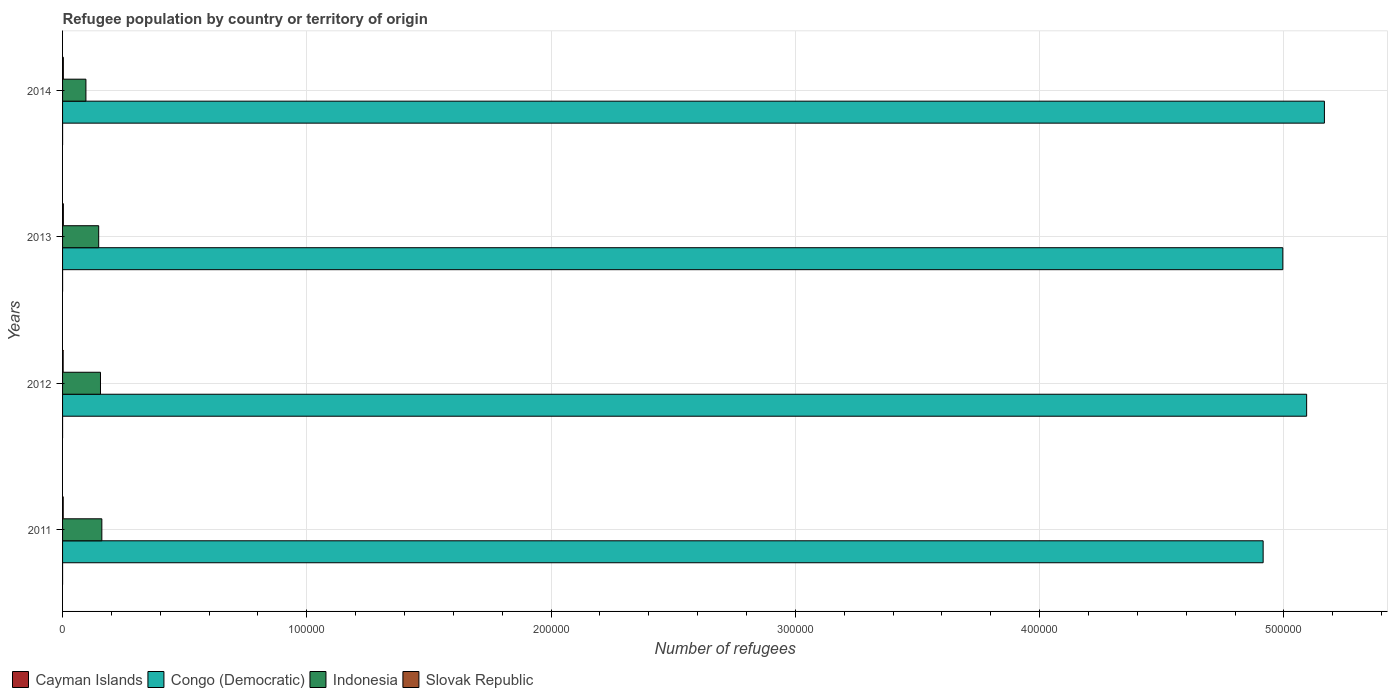How many groups of bars are there?
Keep it short and to the point. 4. Are the number of bars per tick equal to the number of legend labels?
Ensure brevity in your answer.  Yes. Are the number of bars on each tick of the Y-axis equal?
Offer a terse response. Yes. How many bars are there on the 3rd tick from the top?
Provide a short and direct response. 4. What is the number of refugees in Slovak Republic in 2014?
Offer a terse response. 319. Across all years, what is the maximum number of refugees in Congo (Democratic)?
Ensure brevity in your answer.  5.17e+05. Across all years, what is the minimum number of refugees in Indonesia?
Provide a short and direct response. 9562. What is the total number of refugees in Congo (Democratic) in the graph?
Your response must be concise. 2.02e+06. What is the difference between the number of refugees in Slovak Republic in 2011 and that in 2012?
Offer a terse response. 30. What is the difference between the number of refugees in Indonesia in 2011 and the number of refugees in Congo (Democratic) in 2013?
Provide a short and direct response. -4.83e+05. What is the average number of refugees in Slovak Republic per year?
Your answer should be compact. 287.5. In the year 2013, what is the difference between the number of refugees in Slovak Republic and number of refugees in Indonesia?
Offer a very short reply. -1.45e+04. What is the ratio of the number of refugees in Slovak Republic in 2011 to that in 2014?
Ensure brevity in your answer.  0.84. What is the difference between the highest and the second highest number of refugees in Cayman Islands?
Your answer should be compact. 0. What is the difference between the highest and the lowest number of refugees in Indonesia?
Offer a terse response. 6517. In how many years, is the number of refugees in Indonesia greater than the average number of refugees in Indonesia taken over all years?
Provide a short and direct response. 3. Is the sum of the number of refugees in Congo (Democratic) in 2011 and 2014 greater than the maximum number of refugees in Cayman Islands across all years?
Your response must be concise. Yes. What does the 2nd bar from the top in 2012 represents?
Give a very brief answer. Indonesia. How many years are there in the graph?
Your answer should be very brief. 4. Are the values on the major ticks of X-axis written in scientific E-notation?
Your answer should be very brief. No. What is the title of the graph?
Your response must be concise. Refugee population by country or territory of origin. What is the label or title of the X-axis?
Your answer should be very brief. Number of refugees. What is the Number of refugees of Cayman Islands in 2011?
Make the answer very short. 1. What is the Number of refugees of Congo (Democratic) in 2011?
Your answer should be very brief. 4.91e+05. What is the Number of refugees of Indonesia in 2011?
Your response must be concise. 1.61e+04. What is the Number of refugees of Slovak Republic in 2011?
Your answer should be very brief. 269. What is the Number of refugees in Congo (Democratic) in 2012?
Your response must be concise. 5.09e+05. What is the Number of refugees in Indonesia in 2012?
Keep it short and to the point. 1.55e+04. What is the Number of refugees of Slovak Republic in 2012?
Your answer should be very brief. 239. What is the Number of refugees in Congo (Democratic) in 2013?
Ensure brevity in your answer.  5.00e+05. What is the Number of refugees of Indonesia in 2013?
Give a very brief answer. 1.48e+04. What is the Number of refugees of Slovak Republic in 2013?
Provide a succinct answer. 323. What is the Number of refugees in Congo (Democratic) in 2014?
Offer a terse response. 5.17e+05. What is the Number of refugees in Indonesia in 2014?
Keep it short and to the point. 9562. What is the Number of refugees in Slovak Republic in 2014?
Provide a succinct answer. 319. Across all years, what is the maximum Number of refugees in Cayman Islands?
Your response must be concise. 6. Across all years, what is the maximum Number of refugees of Congo (Democratic)?
Make the answer very short. 5.17e+05. Across all years, what is the maximum Number of refugees of Indonesia?
Provide a succinct answer. 1.61e+04. Across all years, what is the maximum Number of refugees of Slovak Republic?
Your answer should be very brief. 323. Across all years, what is the minimum Number of refugees of Congo (Democratic)?
Your response must be concise. 4.91e+05. Across all years, what is the minimum Number of refugees of Indonesia?
Provide a short and direct response. 9562. Across all years, what is the minimum Number of refugees of Slovak Republic?
Make the answer very short. 239. What is the total Number of refugees in Congo (Democratic) in the graph?
Provide a short and direct response. 2.02e+06. What is the total Number of refugees in Indonesia in the graph?
Offer a terse response. 5.60e+04. What is the total Number of refugees in Slovak Republic in the graph?
Your response must be concise. 1150. What is the difference between the Number of refugees of Congo (Democratic) in 2011 and that in 2012?
Give a very brief answer. -1.78e+04. What is the difference between the Number of refugees in Indonesia in 2011 and that in 2012?
Offer a very short reply. 556. What is the difference between the Number of refugees of Slovak Republic in 2011 and that in 2012?
Keep it short and to the point. 30. What is the difference between the Number of refugees in Congo (Democratic) in 2011 and that in 2013?
Offer a terse response. -8060. What is the difference between the Number of refugees of Indonesia in 2011 and that in 2013?
Provide a short and direct response. 1293. What is the difference between the Number of refugees of Slovak Republic in 2011 and that in 2013?
Give a very brief answer. -54. What is the difference between the Number of refugees in Cayman Islands in 2011 and that in 2014?
Your answer should be very brief. -5. What is the difference between the Number of refugees in Congo (Democratic) in 2011 and that in 2014?
Your answer should be very brief. -2.51e+04. What is the difference between the Number of refugees of Indonesia in 2011 and that in 2014?
Provide a short and direct response. 6517. What is the difference between the Number of refugees of Slovak Republic in 2011 and that in 2014?
Provide a short and direct response. -50. What is the difference between the Number of refugees of Congo (Democratic) in 2012 and that in 2013?
Make the answer very short. 9749. What is the difference between the Number of refugees of Indonesia in 2012 and that in 2013?
Ensure brevity in your answer.  737. What is the difference between the Number of refugees of Slovak Republic in 2012 and that in 2013?
Your answer should be compact. -84. What is the difference between the Number of refugees in Cayman Islands in 2012 and that in 2014?
Provide a succinct answer. -5. What is the difference between the Number of refugees of Congo (Democratic) in 2012 and that in 2014?
Your answer should be very brief. -7272. What is the difference between the Number of refugees in Indonesia in 2012 and that in 2014?
Keep it short and to the point. 5961. What is the difference between the Number of refugees of Slovak Republic in 2012 and that in 2014?
Provide a short and direct response. -80. What is the difference between the Number of refugees in Congo (Democratic) in 2013 and that in 2014?
Give a very brief answer. -1.70e+04. What is the difference between the Number of refugees of Indonesia in 2013 and that in 2014?
Give a very brief answer. 5224. What is the difference between the Number of refugees of Cayman Islands in 2011 and the Number of refugees of Congo (Democratic) in 2012?
Your response must be concise. -5.09e+05. What is the difference between the Number of refugees in Cayman Islands in 2011 and the Number of refugees in Indonesia in 2012?
Provide a short and direct response. -1.55e+04. What is the difference between the Number of refugees in Cayman Islands in 2011 and the Number of refugees in Slovak Republic in 2012?
Offer a terse response. -238. What is the difference between the Number of refugees of Congo (Democratic) in 2011 and the Number of refugees of Indonesia in 2012?
Offer a very short reply. 4.76e+05. What is the difference between the Number of refugees of Congo (Democratic) in 2011 and the Number of refugees of Slovak Republic in 2012?
Your answer should be compact. 4.91e+05. What is the difference between the Number of refugees of Indonesia in 2011 and the Number of refugees of Slovak Republic in 2012?
Keep it short and to the point. 1.58e+04. What is the difference between the Number of refugees of Cayman Islands in 2011 and the Number of refugees of Congo (Democratic) in 2013?
Keep it short and to the point. -5.00e+05. What is the difference between the Number of refugees of Cayman Islands in 2011 and the Number of refugees of Indonesia in 2013?
Ensure brevity in your answer.  -1.48e+04. What is the difference between the Number of refugees of Cayman Islands in 2011 and the Number of refugees of Slovak Republic in 2013?
Offer a terse response. -322. What is the difference between the Number of refugees in Congo (Democratic) in 2011 and the Number of refugees in Indonesia in 2013?
Provide a succinct answer. 4.77e+05. What is the difference between the Number of refugees of Congo (Democratic) in 2011 and the Number of refugees of Slovak Republic in 2013?
Give a very brief answer. 4.91e+05. What is the difference between the Number of refugees of Indonesia in 2011 and the Number of refugees of Slovak Republic in 2013?
Provide a short and direct response. 1.58e+04. What is the difference between the Number of refugees of Cayman Islands in 2011 and the Number of refugees of Congo (Democratic) in 2014?
Your response must be concise. -5.17e+05. What is the difference between the Number of refugees in Cayman Islands in 2011 and the Number of refugees in Indonesia in 2014?
Offer a terse response. -9561. What is the difference between the Number of refugees of Cayman Islands in 2011 and the Number of refugees of Slovak Republic in 2014?
Your response must be concise. -318. What is the difference between the Number of refugees of Congo (Democratic) in 2011 and the Number of refugees of Indonesia in 2014?
Make the answer very short. 4.82e+05. What is the difference between the Number of refugees of Congo (Democratic) in 2011 and the Number of refugees of Slovak Republic in 2014?
Your response must be concise. 4.91e+05. What is the difference between the Number of refugees of Indonesia in 2011 and the Number of refugees of Slovak Republic in 2014?
Your response must be concise. 1.58e+04. What is the difference between the Number of refugees of Cayman Islands in 2012 and the Number of refugees of Congo (Democratic) in 2013?
Provide a succinct answer. -5.00e+05. What is the difference between the Number of refugees in Cayman Islands in 2012 and the Number of refugees in Indonesia in 2013?
Ensure brevity in your answer.  -1.48e+04. What is the difference between the Number of refugees of Cayman Islands in 2012 and the Number of refugees of Slovak Republic in 2013?
Make the answer very short. -322. What is the difference between the Number of refugees in Congo (Democratic) in 2012 and the Number of refugees in Indonesia in 2013?
Give a very brief answer. 4.95e+05. What is the difference between the Number of refugees of Congo (Democratic) in 2012 and the Number of refugees of Slovak Republic in 2013?
Offer a terse response. 5.09e+05. What is the difference between the Number of refugees of Indonesia in 2012 and the Number of refugees of Slovak Republic in 2013?
Ensure brevity in your answer.  1.52e+04. What is the difference between the Number of refugees of Cayman Islands in 2012 and the Number of refugees of Congo (Democratic) in 2014?
Your response must be concise. -5.17e+05. What is the difference between the Number of refugees in Cayman Islands in 2012 and the Number of refugees in Indonesia in 2014?
Offer a very short reply. -9561. What is the difference between the Number of refugees of Cayman Islands in 2012 and the Number of refugees of Slovak Republic in 2014?
Provide a short and direct response. -318. What is the difference between the Number of refugees in Congo (Democratic) in 2012 and the Number of refugees in Indonesia in 2014?
Your answer should be compact. 5.00e+05. What is the difference between the Number of refugees of Congo (Democratic) in 2012 and the Number of refugees of Slovak Republic in 2014?
Your answer should be compact. 5.09e+05. What is the difference between the Number of refugees in Indonesia in 2012 and the Number of refugees in Slovak Republic in 2014?
Keep it short and to the point. 1.52e+04. What is the difference between the Number of refugees in Cayman Islands in 2013 and the Number of refugees in Congo (Democratic) in 2014?
Make the answer very short. -5.17e+05. What is the difference between the Number of refugees in Cayman Islands in 2013 and the Number of refugees in Indonesia in 2014?
Keep it short and to the point. -9556. What is the difference between the Number of refugees in Cayman Islands in 2013 and the Number of refugees in Slovak Republic in 2014?
Provide a succinct answer. -313. What is the difference between the Number of refugees in Congo (Democratic) in 2013 and the Number of refugees in Indonesia in 2014?
Your response must be concise. 4.90e+05. What is the difference between the Number of refugees in Congo (Democratic) in 2013 and the Number of refugees in Slovak Republic in 2014?
Provide a succinct answer. 4.99e+05. What is the difference between the Number of refugees in Indonesia in 2013 and the Number of refugees in Slovak Republic in 2014?
Keep it short and to the point. 1.45e+04. What is the average Number of refugees of Congo (Democratic) per year?
Offer a very short reply. 5.04e+05. What is the average Number of refugees of Indonesia per year?
Offer a terse response. 1.40e+04. What is the average Number of refugees in Slovak Republic per year?
Keep it short and to the point. 287.5. In the year 2011, what is the difference between the Number of refugees in Cayman Islands and Number of refugees in Congo (Democratic)?
Keep it short and to the point. -4.91e+05. In the year 2011, what is the difference between the Number of refugees in Cayman Islands and Number of refugees in Indonesia?
Provide a succinct answer. -1.61e+04. In the year 2011, what is the difference between the Number of refugees in Cayman Islands and Number of refugees in Slovak Republic?
Offer a very short reply. -268. In the year 2011, what is the difference between the Number of refugees in Congo (Democratic) and Number of refugees in Indonesia?
Provide a succinct answer. 4.75e+05. In the year 2011, what is the difference between the Number of refugees in Congo (Democratic) and Number of refugees in Slovak Republic?
Your answer should be compact. 4.91e+05. In the year 2011, what is the difference between the Number of refugees in Indonesia and Number of refugees in Slovak Republic?
Your response must be concise. 1.58e+04. In the year 2012, what is the difference between the Number of refugees in Cayman Islands and Number of refugees in Congo (Democratic)?
Keep it short and to the point. -5.09e+05. In the year 2012, what is the difference between the Number of refugees of Cayman Islands and Number of refugees of Indonesia?
Make the answer very short. -1.55e+04. In the year 2012, what is the difference between the Number of refugees of Cayman Islands and Number of refugees of Slovak Republic?
Your answer should be compact. -238. In the year 2012, what is the difference between the Number of refugees in Congo (Democratic) and Number of refugees in Indonesia?
Provide a succinct answer. 4.94e+05. In the year 2012, what is the difference between the Number of refugees of Congo (Democratic) and Number of refugees of Slovak Republic?
Ensure brevity in your answer.  5.09e+05. In the year 2012, what is the difference between the Number of refugees of Indonesia and Number of refugees of Slovak Republic?
Offer a terse response. 1.53e+04. In the year 2013, what is the difference between the Number of refugees of Cayman Islands and Number of refugees of Congo (Democratic)?
Give a very brief answer. -5.00e+05. In the year 2013, what is the difference between the Number of refugees of Cayman Islands and Number of refugees of Indonesia?
Your answer should be very brief. -1.48e+04. In the year 2013, what is the difference between the Number of refugees in Cayman Islands and Number of refugees in Slovak Republic?
Your response must be concise. -317. In the year 2013, what is the difference between the Number of refugees in Congo (Democratic) and Number of refugees in Indonesia?
Make the answer very short. 4.85e+05. In the year 2013, what is the difference between the Number of refugees in Congo (Democratic) and Number of refugees in Slovak Republic?
Offer a very short reply. 4.99e+05. In the year 2013, what is the difference between the Number of refugees in Indonesia and Number of refugees in Slovak Republic?
Make the answer very short. 1.45e+04. In the year 2014, what is the difference between the Number of refugees of Cayman Islands and Number of refugees of Congo (Democratic)?
Offer a terse response. -5.17e+05. In the year 2014, what is the difference between the Number of refugees of Cayman Islands and Number of refugees of Indonesia?
Offer a terse response. -9556. In the year 2014, what is the difference between the Number of refugees in Cayman Islands and Number of refugees in Slovak Republic?
Provide a short and direct response. -313. In the year 2014, what is the difference between the Number of refugees in Congo (Democratic) and Number of refugees in Indonesia?
Provide a short and direct response. 5.07e+05. In the year 2014, what is the difference between the Number of refugees of Congo (Democratic) and Number of refugees of Slovak Republic?
Ensure brevity in your answer.  5.16e+05. In the year 2014, what is the difference between the Number of refugees of Indonesia and Number of refugees of Slovak Republic?
Your answer should be very brief. 9243. What is the ratio of the Number of refugees in Cayman Islands in 2011 to that in 2012?
Provide a short and direct response. 1. What is the ratio of the Number of refugees of Indonesia in 2011 to that in 2012?
Offer a very short reply. 1.04. What is the ratio of the Number of refugees of Slovak Republic in 2011 to that in 2012?
Give a very brief answer. 1.13. What is the ratio of the Number of refugees of Congo (Democratic) in 2011 to that in 2013?
Offer a terse response. 0.98. What is the ratio of the Number of refugees in Indonesia in 2011 to that in 2013?
Keep it short and to the point. 1.09. What is the ratio of the Number of refugees in Slovak Republic in 2011 to that in 2013?
Ensure brevity in your answer.  0.83. What is the ratio of the Number of refugees of Congo (Democratic) in 2011 to that in 2014?
Provide a short and direct response. 0.95. What is the ratio of the Number of refugees in Indonesia in 2011 to that in 2014?
Your answer should be compact. 1.68. What is the ratio of the Number of refugees in Slovak Republic in 2011 to that in 2014?
Your answer should be compact. 0.84. What is the ratio of the Number of refugees in Cayman Islands in 2012 to that in 2013?
Offer a very short reply. 0.17. What is the ratio of the Number of refugees of Congo (Democratic) in 2012 to that in 2013?
Offer a very short reply. 1.02. What is the ratio of the Number of refugees of Indonesia in 2012 to that in 2013?
Your response must be concise. 1.05. What is the ratio of the Number of refugees of Slovak Republic in 2012 to that in 2013?
Provide a succinct answer. 0.74. What is the ratio of the Number of refugees of Congo (Democratic) in 2012 to that in 2014?
Offer a very short reply. 0.99. What is the ratio of the Number of refugees of Indonesia in 2012 to that in 2014?
Your answer should be compact. 1.62. What is the ratio of the Number of refugees in Slovak Republic in 2012 to that in 2014?
Your response must be concise. 0.75. What is the ratio of the Number of refugees of Indonesia in 2013 to that in 2014?
Your answer should be compact. 1.55. What is the ratio of the Number of refugees in Slovak Republic in 2013 to that in 2014?
Your answer should be compact. 1.01. What is the difference between the highest and the second highest Number of refugees of Cayman Islands?
Your response must be concise. 0. What is the difference between the highest and the second highest Number of refugees of Congo (Democratic)?
Provide a short and direct response. 7272. What is the difference between the highest and the second highest Number of refugees of Indonesia?
Provide a short and direct response. 556. What is the difference between the highest and the lowest Number of refugees in Congo (Democratic)?
Give a very brief answer. 2.51e+04. What is the difference between the highest and the lowest Number of refugees in Indonesia?
Your answer should be very brief. 6517. What is the difference between the highest and the lowest Number of refugees of Slovak Republic?
Your answer should be compact. 84. 